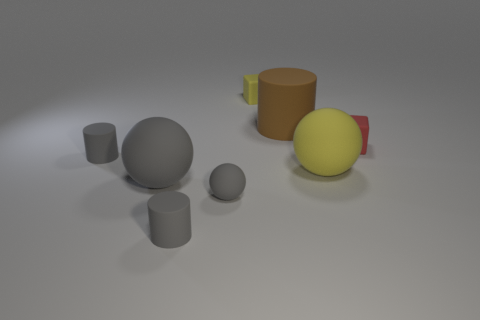What is the color of the large object behind the gray rubber cylinder that is behind the tiny matte sphere?
Offer a very short reply. Brown. Do the brown object and the large yellow matte object have the same shape?
Provide a succinct answer. No. What material is the other tiny thing that is the same shape as the small red object?
Ensure brevity in your answer.  Rubber. Is there a large yellow matte ball that is behind the rubber cube that is in front of the matte cube that is behind the red thing?
Make the answer very short. No. There is a large gray matte object; is it the same shape as the thing behind the big brown rubber cylinder?
Provide a short and direct response. No. Is there anything else of the same color as the tiny rubber sphere?
Give a very brief answer. Yes. Does the large ball right of the small rubber sphere have the same color as the big thing that is behind the yellow matte sphere?
Keep it short and to the point. No. Are any big gray balls visible?
Make the answer very short. Yes. Are there any blocks made of the same material as the small red thing?
Provide a succinct answer. Yes. Are there any other things that have the same material as the large yellow sphere?
Your answer should be compact. Yes. 